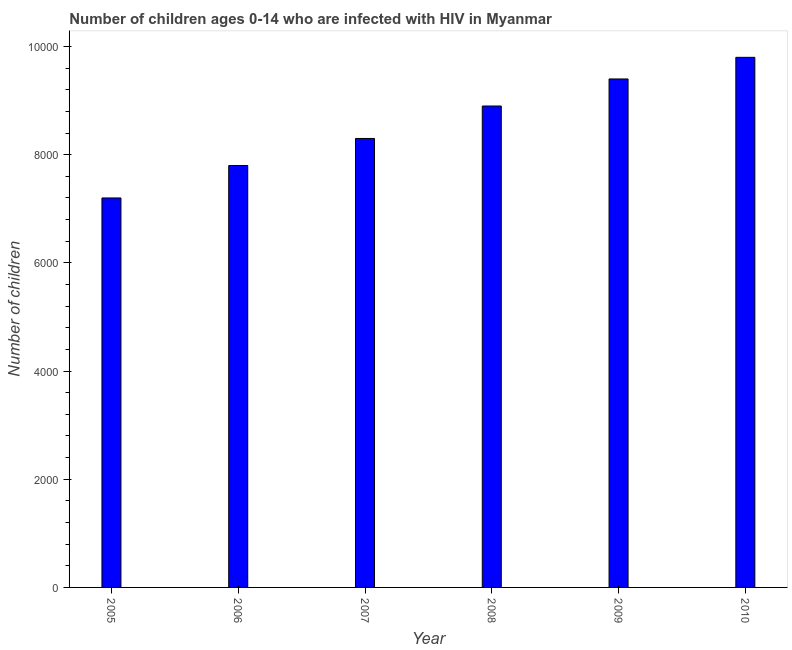What is the title of the graph?
Make the answer very short. Number of children ages 0-14 who are infected with HIV in Myanmar. What is the label or title of the Y-axis?
Give a very brief answer. Number of children. What is the number of children living with hiv in 2005?
Your answer should be compact. 7200. Across all years, what is the maximum number of children living with hiv?
Your response must be concise. 9800. Across all years, what is the minimum number of children living with hiv?
Ensure brevity in your answer.  7200. In which year was the number of children living with hiv maximum?
Make the answer very short. 2010. In which year was the number of children living with hiv minimum?
Offer a very short reply. 2005. What is the sum of the number of children living with hiv?
Make the answer very short. 5.14e+04. What is the difference between the number of children living with hiv in 2008 and 2010?
Your answer should be very brief. -900. What is the average number of children living with hiv per year?
Keep it short and to the point. 8566. What is the median number of children living with hiv?
Keep it short and to the point. 8600. In how many years, is the number of children living with hiv greater than 6000 ?
Make the answer very short. 6. What is the ratio of the number of children living with hiv in 2008 to that in 2010?
Give a very brief answer. 0.91. What is the difference between the highest and the second highest number of children living with hiv?
Your response must be concise. 400. Is the sum of the number of children living with hiv in 2005 and 2009 greater than the maximum number of children living with hiv across all years?
Provide a short and direct response. Yes. What is the difference between the highest and the lowest number of children living with hiv?
Make the answer very short. 2600. What is the difference between two consecutive major ticks on the Y-axis?
Your answer should be very brief. 2000. Are the values on the major ticks of Y-axis written in scientific E-notation?
Provide a succinct answer. No. What is the Number of children in 2005?
Make the answer very short. 7200. What is the Number of children of 2006?
Keep it short and to the point. 7800. What is the Number of children of 2007?
Your response must be concise. 8300. What is the Number of children in 2008?
Offer a very short reply. 8900. What is the Number of children of 2009?
Make the answer very short. 9400. What is the Number of children of 2010?
Your answer should be very brief. 9800. What is the difference between the Number of children in 2005 and 2006?
Offer a very short reply. -600. What is the difference between the Number of children in 2005 and 2007?
Your response must be concise. -1100. What is the difference between the Number of children in 2005 and 2008?
Keep it short and to the point. -1700. What is the difference between the Number of children in 2005 and 2009?
Offer a very short reply. -2200. What is the difference between the Number of children in 2005 and 2010?
Make the answer very short. -2600. What is the difference between the Number of children in 2006 and 2007?
Ensure brevity in your answer.  -500. What is the difference between the Number of children in 2006 and 2008?
Keep it short and to the point. -1100. What is the difference between the Number of children in 2006 and 2009?
Offer a very short reply. -1600. What is the difference between the Number of children in 2006 and 2010?
Ensure brevity in your answer.  -2000. What is the difference between the Number of children in 2007 and 2008?
Provide a succinct answer. -600. What is the difference between the Number of children in 2007 and 2009?
Keep it short and to the point. -1100. What is the difference between the Number of children in 2007 and 2010?
Your answer should be very brief. -1500. What is the difference between the Number of children in 2008 and 2009?
Give a very brief answer. -500. What is the difference between the Number of children in 2008 and 2010?
Keep it short and to the point. -900. What is the difference between the Number of children in 2009 and 2010?
Your response must be concise. -400. What is the ratio of the Number of children in 2005 to that in 2006?
Your answer should be very brief. 0.92. What is the ratio of the Number of children in 2005 to that in 2007?
Offer a very short reply. 0.87. What is the ratio of the Number of children in 2005 to that in 2008?
Keep it short and to the point. 0.81. What is the ratio of the Number of children in 2005 to that in 2009?
Give a very brief answer. 0.77. What is the ratio of the Number of children in 2005 to that in 2010?
Offer a terse response. 0.73. What is the ratio of the Number of children in 2006 to that in 2008?
Your response must be concise. 0.88. What is the ratio of the Number of children in 2006 to that in 2009?
Offer a very short reply. 0.83. What is the ratio of the Number of children in 2006 to that in 2010?
Give a very brief answer. 0.8. What is the ratio of the Number of children in 2007 to that in 2008?
Keep it short and to the point. 0.93. What is the ratio of the Number of children in 2007 to that in 2009?
Give a very brief answer. 0.88. What is the ratio of the Number of children in 2007 to that in 2010?
Offer a very short reply. 0.85. What is the ratio of the Number of children in 2008 to that in 2009?
Ensure brevity in your answer.  0.95. What is the ratio of the Number of children in 2008 to that in 2010?
Offer a terse response. 0.91. 